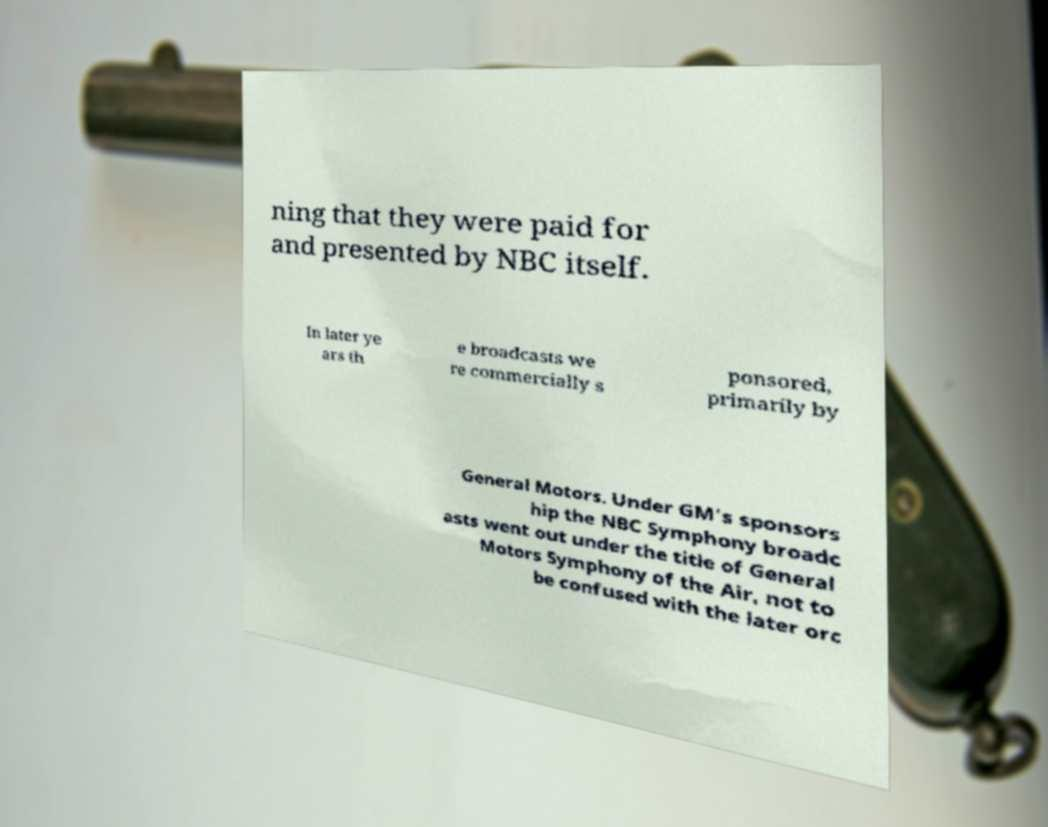Can you read and provide the text displayed in the image?This photo seems to have some interesting text. Can you extract and type it out for me? ning that they were paid for and presented by NBC itself. In later ye ars th e broadcasts we re commercially s ponsored, primarily by General Motors. Under GM's sponsors hip the NBC Symphony broadc asts went out under the title of General Motors Symphony of the Air, not to be confused with the later orc 